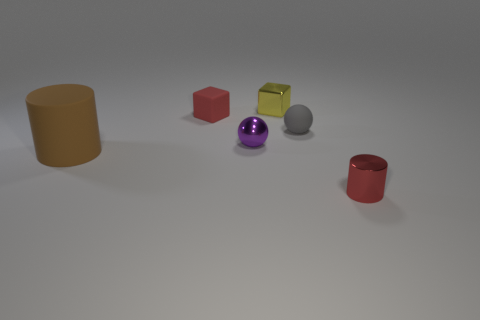Add 2 blue metallic blocks. How many objects exist? 8 Subtract all cylinders. How many objects are left? 4 Subtract all cyan spheres. Subtract all blue cylinders. How many spheres are left? 2 Subtract all gray balls. How many green cylinders are left? 0 Subtract all brown cylinders. Subtract all tiny gray balls. How many objects are left? 4 Add 1 large things. How many large things are left? 2 Add 1 small red things. How many small red things exist? 3 Subtract 0 red balls. How many objects are left? 6 